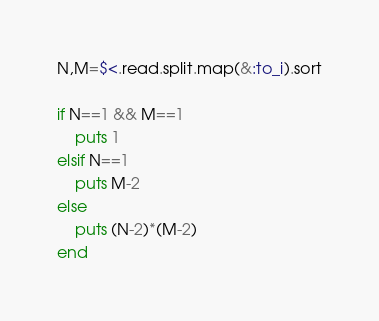<code> <loc_0><loc_0><loc_500><loc_500><_Ruby_>N,M=$<.read.split.map(&:to_i).sort

if N==1 && M==1
    puts 1
elsif N==1
    puts M-2
else
    puts (N-2)*(M-2)
end</code> 